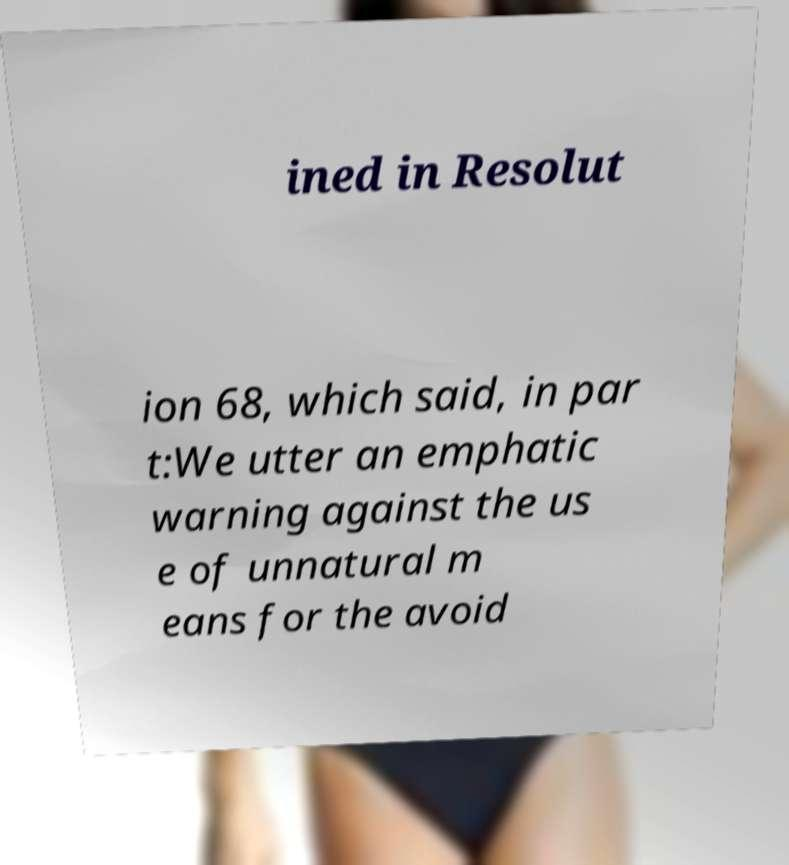Please read and relay the text visible in this image. What does it say? ined in Resolut ion 68, which said, in par t:We utter an emphatic warning against the us e of unnatural m eans for the avoid 